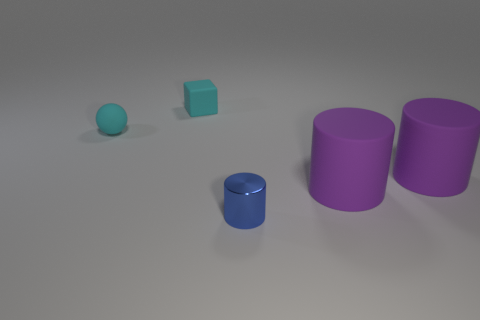There is a small object in front of the cyan matte object that is to the left of the cyan rubber block; what is it made of?
Your answer should be compact. Metal. The tiny thing that is both to the right of the tiny matte ball and in front of the small cyan block has what shape?
Ensure brevity in your answer.  Cylinder. How many other objects are there of the same color as the shiny object?
Ensure brevity in your answer.  0. How many things are either small blue objects that are to the right of the small rubber cube or small blue shiny cylinders?
Give a very brief answer. 1. There is a tiny block; does it have the same color as the thing on the left side of the cyan matte block?
Offer a very short reply. Yes. How big is the cyan matte thing that is on the left side of the small thing behind the tiny cyan rubber sphere?
Your answer should be very brief. Small. What number of things are tiny objects or tiny things that are on the left side of the shiny thing?
Your answer should be compact. 3. Is the shape of the small cyan rubber object that is in front of the tiny cyan block the same as  the metal thing?
Your answer should be very brief. No. What number of small metal things are right of the small thing that is behind the small cyan object that is left of the cyan matte cube?
Provide a short and direct response. 1. What number of things are big balls or large cylinders?
Ensure brevity in your answer.  2. 